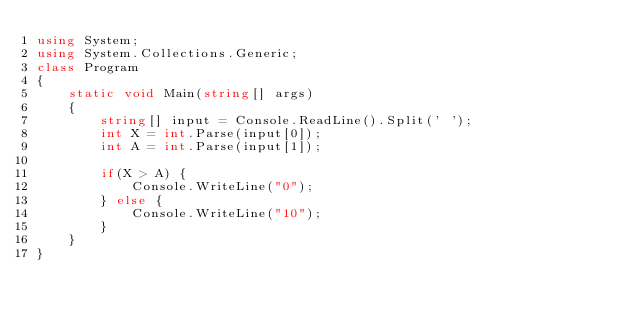Convert code to text. <code><loc_0><loc_0><loc_500><loc_500><_C#_>using System;
using System.Collections.Generic;
class Program
{
    static void Main(string[] args)
    {
        string[] input = Console.ReadLine().Split(' ');
        int X = int.Parse(input[0]);
        int A = int.Parse(input[1]);

        if(X > A) {
            Console.WriteLine("0");
        } else {
            Console.WriteLine("10");
        }        
    }
}
</code> 